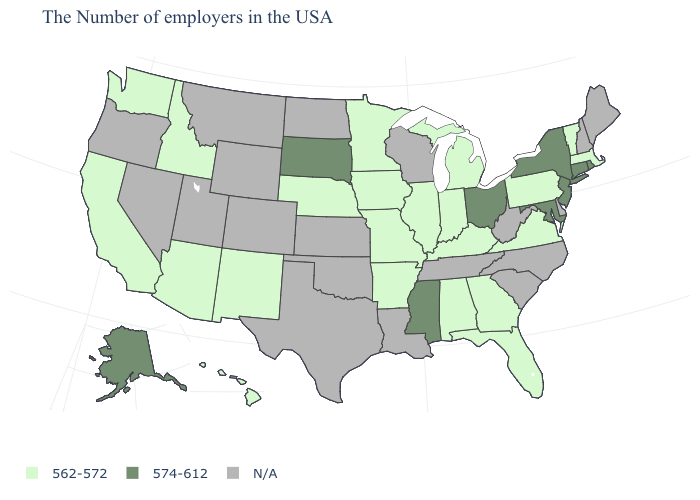How many symbols are there in the legend?
Short answer required. 3. What is the highest value in the Northeast ?
Concise answer only. 574-612. What is the highest value in the USA?
Be succinct. 574-612. Is the legend a continuous bar?
Write a very short answer. No. What is the value of Colorado?
Keep it brief. N/A. Does the map have missing data?
Concise answer only. Yes. How many symbols are there in the legend?
Concise answer only. 3. What is the value of Maine?
Quick response, please. N/A. Name the states that have a value in the range 562-572?
Answer briefly. Massachusetts, Vermont, Pennsylvania, Virginia, Florida, Georgia, Michigan, Kentucky, Indiana, Alabama, Illinois, Missouri, Arkansas, Minnesota, Iowa, Nebraska, New Mexico, Arizona, Idaho, California, Washington, Hawaii. What is the value of Tennessee?
Answer briefly. N/A. Among the states that border North Dakota , which have the lowest value?
Write a very short answer. Minnesota. What is the highest value in the MidWest ?
Write a very short answer. 574-612. Does the map have missing data?
Answer briefly. Yes. What is the value of Michigan?
Answer briefly. 562-572. 